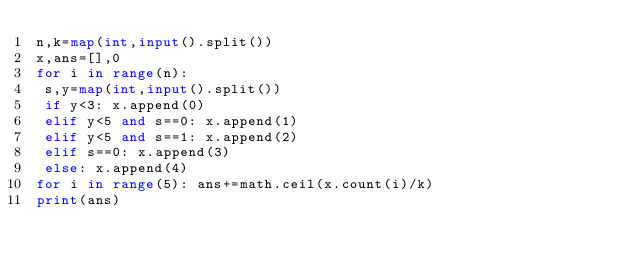Convert code to text. <code><loc_0><loc_0><loc_500><loc_500><_Python_>n,k=map(int,input().split())
x,ans=[],0
for i in range(n):
 s,y=map(int,input().split())
 if y<3: x.append(0)
 elif y<5 and s==0: x.append(1)
 elif y<5 and s==1: x.append(2)
 elif s==0: x.append(3)
 else: x.append(4)
for i in range(5): ans+=math.ceil(x.count(i)/k)
print(ans)</code> 